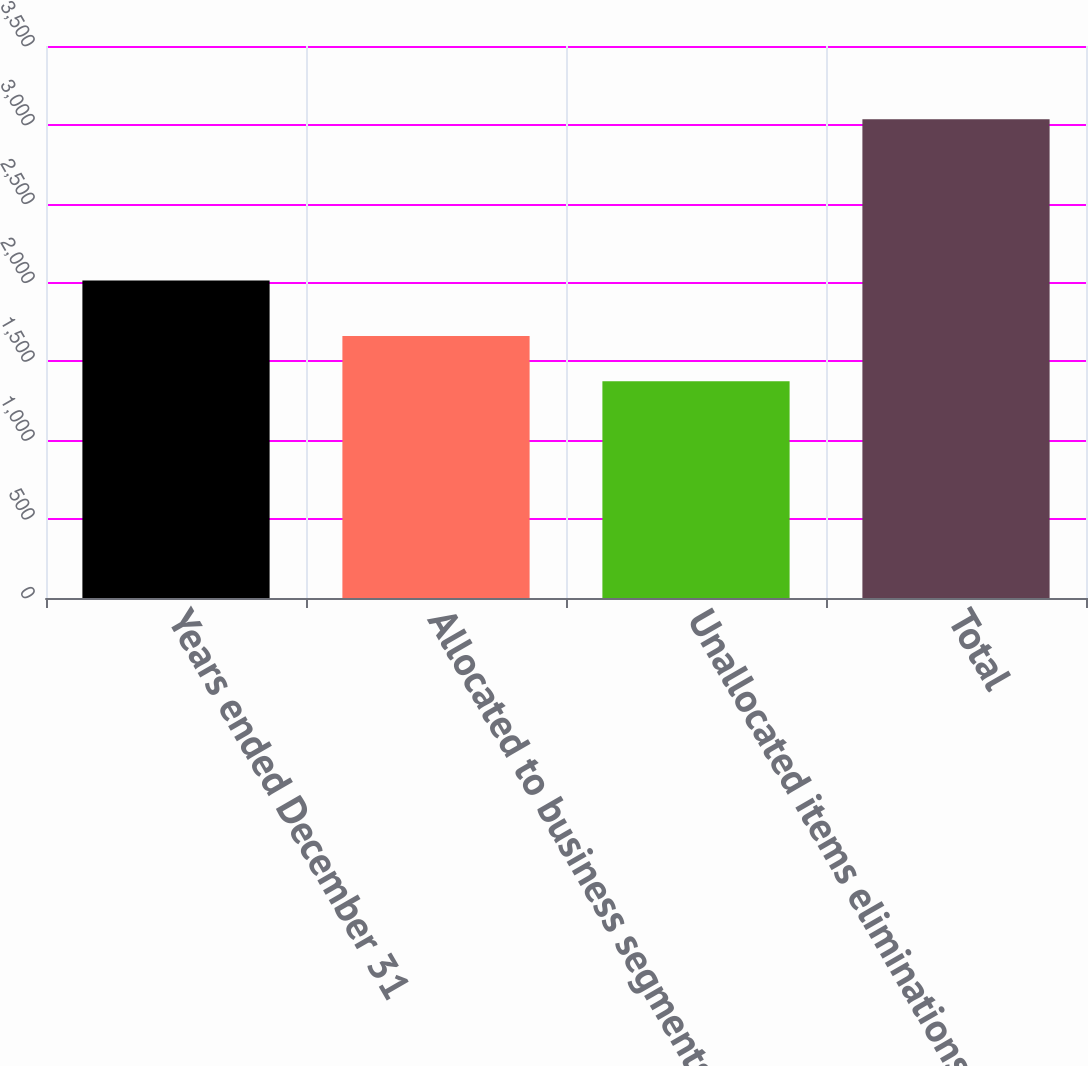<chart> <loc_0><loc_0><loc_500><loc_500><bar_chart><fcel>Years ended December 31<fcel>Allocated to business segments<fcel>Unallocated items eliminations<fcel>Total<nl><fcel>2013<fcel>1662<fcel>1374<fcel>3036<nl></chart> 